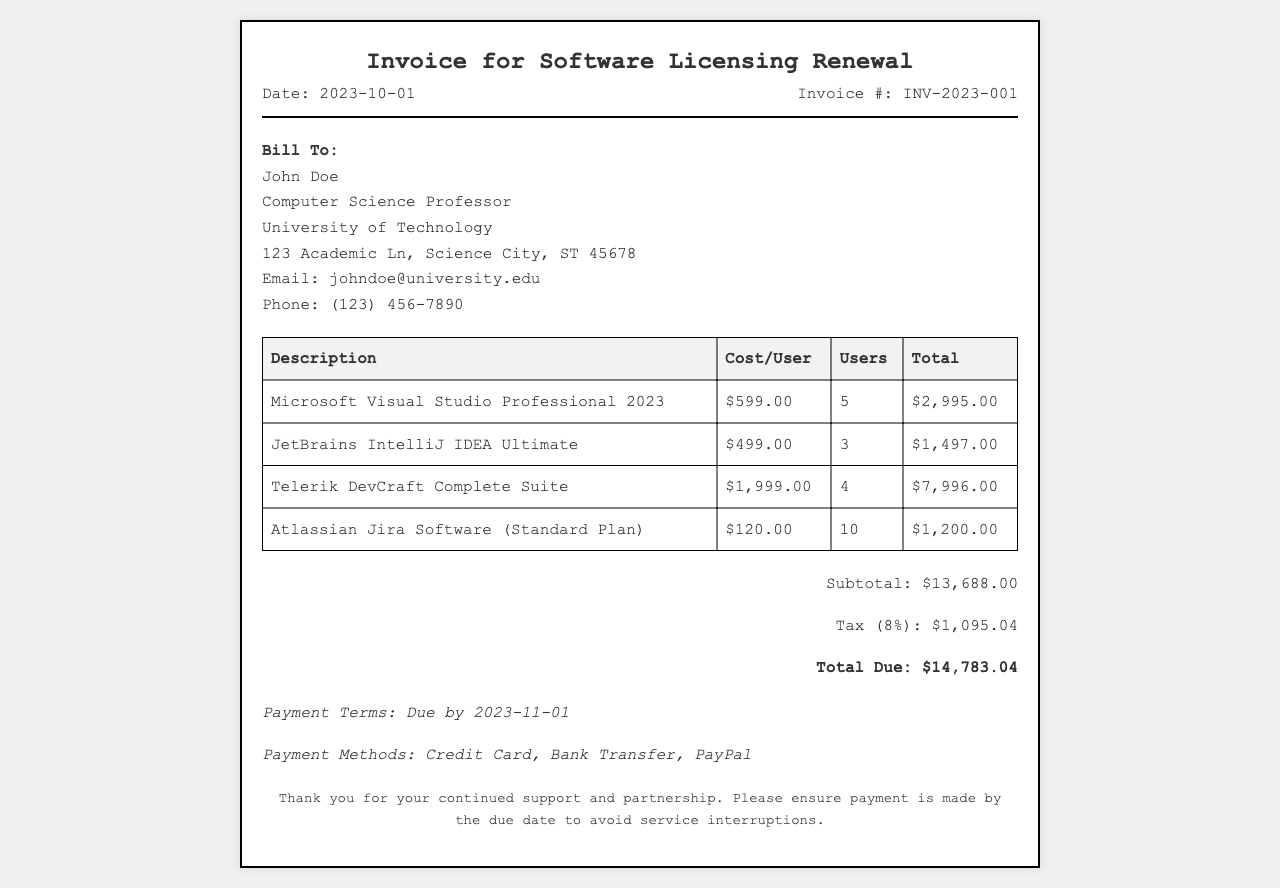What is the invoice number? The invoice number is stated clearly at the top of the document under the date.
Answer: INV-2023-001 How many users are listed for Microsoft Visual Studio Professional 2023? The number of users for this software is specified in the corresponding row of the table.
Answer: 5 What is the subtotal amount before tax? The subtotal is provided in the total section, detailing the amount before taxes are added.
Answer: $13,688.00 What is the total due amount including tax? The total due is indicated at the end of the invoice, which includes the subtotal and tax.
Answer: $14,783.04 What is the tax rate applied to the subtotal? The tax rate is mentioned in the total section and is reflected as a percentage of the subtotal.
Answer: 8% What is the cost per user for JetBrains IntelliJ IDEA Ultimate? The cost per user for this tool is located in the table under the "Cost/User" column.
Answer: $499.00 How many total software tools are listed in the invoice? The total number of software tools can be counted from the rows in the table.
Answer: 4 What is the payment due date? The due date for payment is specified in the payment terms section of the invoice.
Answer: 2023-11-01 What is the billing address for the invoice? The billing address is detailed in the section labeled "Bill To" at the start of the invoice.
Answer: John Doe, Computer Science Professor, University of Technology, 123 Academic Ln, Science City, ST 45678 